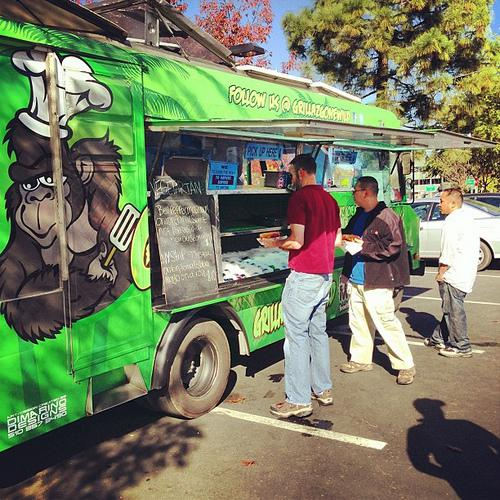Question: what has a gorilla on it?
Choices:
A. A lunch truck.
B. A lunch box.
C. A shirt.
D. A picture.
Answer with the letter. Answer: A Question: who do you see in the scene?
Choices:
A. Women.
B. Animals.
C. Men.
D. Children.
Answer with the letter. Answer: C Question: how many men do you see?
Choices:
A. 5.
B. 6.
C. 3.
D. 1.
Answer with the letter. Answer: C Question: what can you see in the background?
Choices:
A. Planes.
B. Trains.
C. Automobiles.
D. Cars.
Answer with the letter. Answer: D Question: where is the location of this picture?
Choices:
A. The beach.
B. A parking lot.
C. The stables.
D. A theater.
Answer with the letter. Answer: B Question: how is the weather in the picture?
Choices:
A. Rainy.
B. Gloomy.
C. Snowy.
D. Sunny and warm.
Answer with the letter. Answer: D 